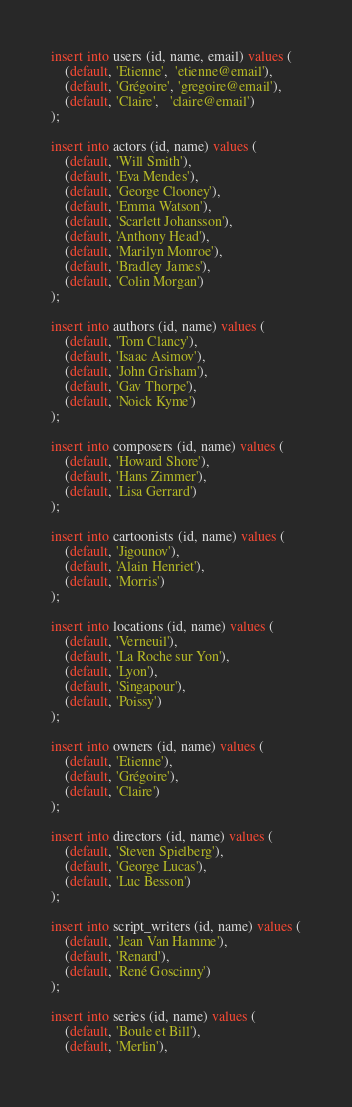<code> <loc_0><loc_0><loc_500><loc_500><_SQL_>insert into users (id, name, email) values (
	(default, 'Etienne',  'etienne@email'),
	(default, 'Grégoire', 'gregoire@email'),
	(default, 'Claire',   'claire@email')
);

insert into actors (id, name) values (
	(default, 'Will Smith'),
	(default, 'Eva Mendes'),
	(default, 'George Clooney'),
	(default, 'Emma Watson'),
	(default, 'Scarlett Johansson'),
	(default, 'Anthony Head'),
	(default, 'Marilyn Monroe'),
	(default, 'Bradley James'),
	(default, 'Colin Morgan')
);

insert into authors (id, name) values (
	(default, 'Tom Clancy'),
	(default, 'Isaac Asimov'),
	(default, 'John Grisham'),
	(default, 'Gav Thorpe'),
	(default, 'Noick Kyme')
);

insert into composers (id, name) values (
	(default, 'Howard Shore'),
	(default, 'Hans Zimmer'),
	(default, 'Lisa Gerrard')
);

insert into cartoonists (id, name) values (
	(default, 'Jigounov'),
	(default, 'Alain Henriet'),
	(default, 'Morris')
);

insert into locations (id, name) values (
	(default, 'Verneuil'),
	(default, 'La Roche sur Yon'),
	(default, 'Lyon'),
	(default, 'Singapour'),
	(default, 'Poissy')
);

insert into owners (id, name) values (
	(default, 'Etienne'),
	(default, 'Grégoire'),
	(default, 'Claire')
);

insert into directors (id, name) values (
	(default, 'Steven Spielberg'),
	(default, 'George Lucas'),
	(default, 'Luc Besson')
);

insert into script_writers (id, name) values (
	(default, 'Jean Van Hamme'),
	(default, 'Renard'),
	(default, 'René Goscinny')
);

insert into series (id, name) values (
	(default, 'Boule et Bill'),
	(default, 'Merlin'),</code> 